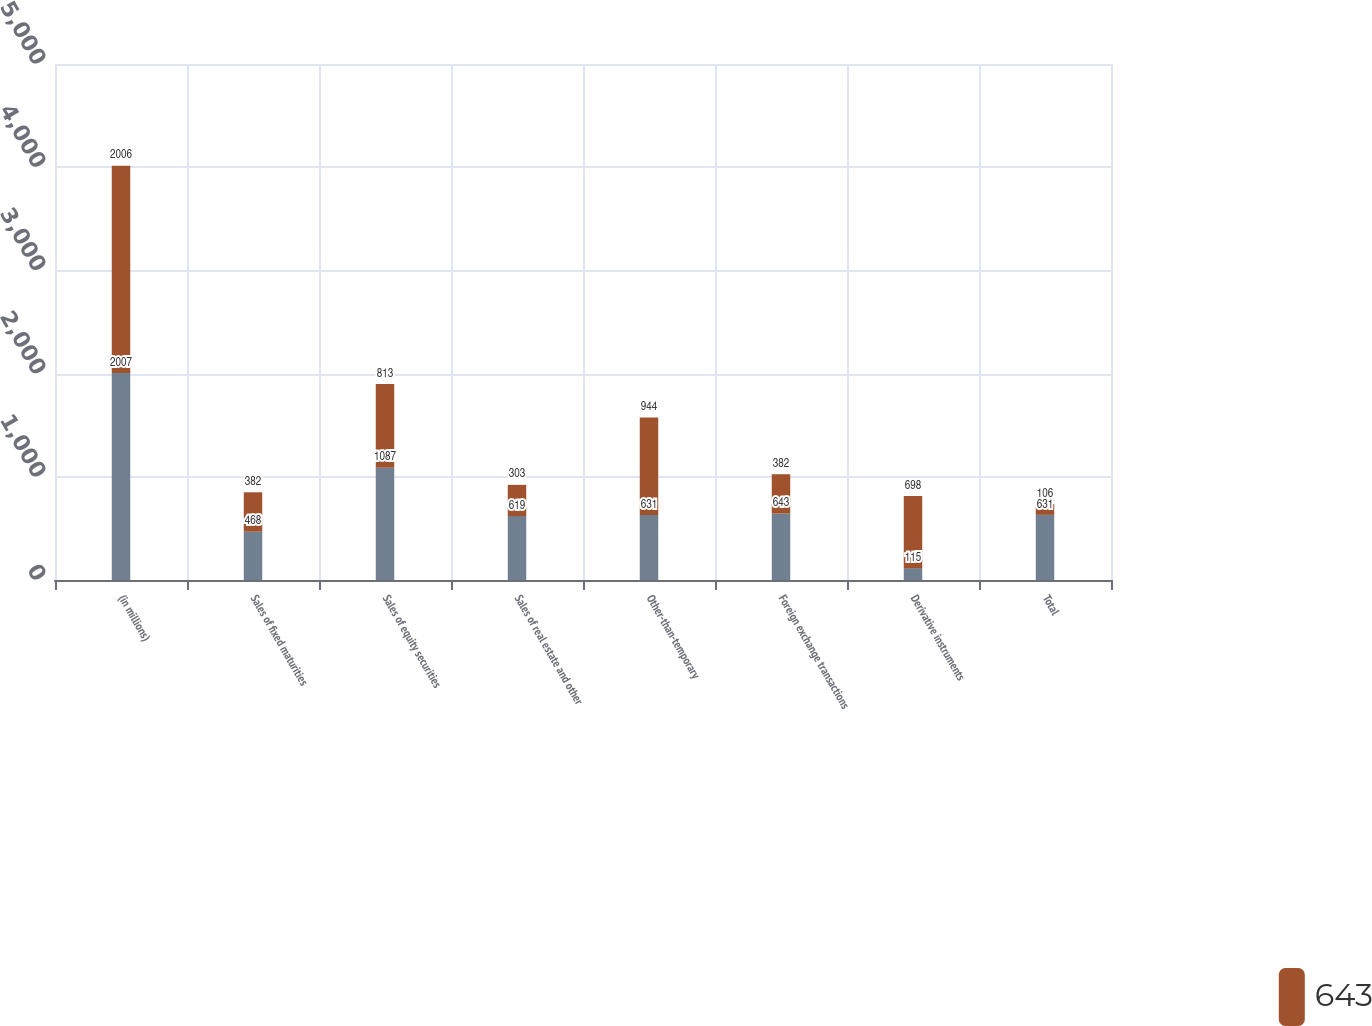Convert chart to OTSL. <chart><loc_0><loc_0><loc_500><loc_500><stacked_bar_chart><ecel><fcel>(in millions)<fcel>Sales of fixed maturities<fcel>Sales of equity securities<fcel>Sales of real estate and other<fcel>Other-than-temporary<fcel>Foreign exchange transactions<fcel>Derivative instruments<fcel>Total<nl><fcel>nan<fcel>2007<fcel>468<fcel>1087<fcel>619<fcel>631<fcel>643<fcel>115<fcel>631<nl><fcel>643<fcel>2006<fcel>382<fcel>813<fcel>303<fcel>944<fcel>382<fcel>698<fcel>106<nl></chart> 